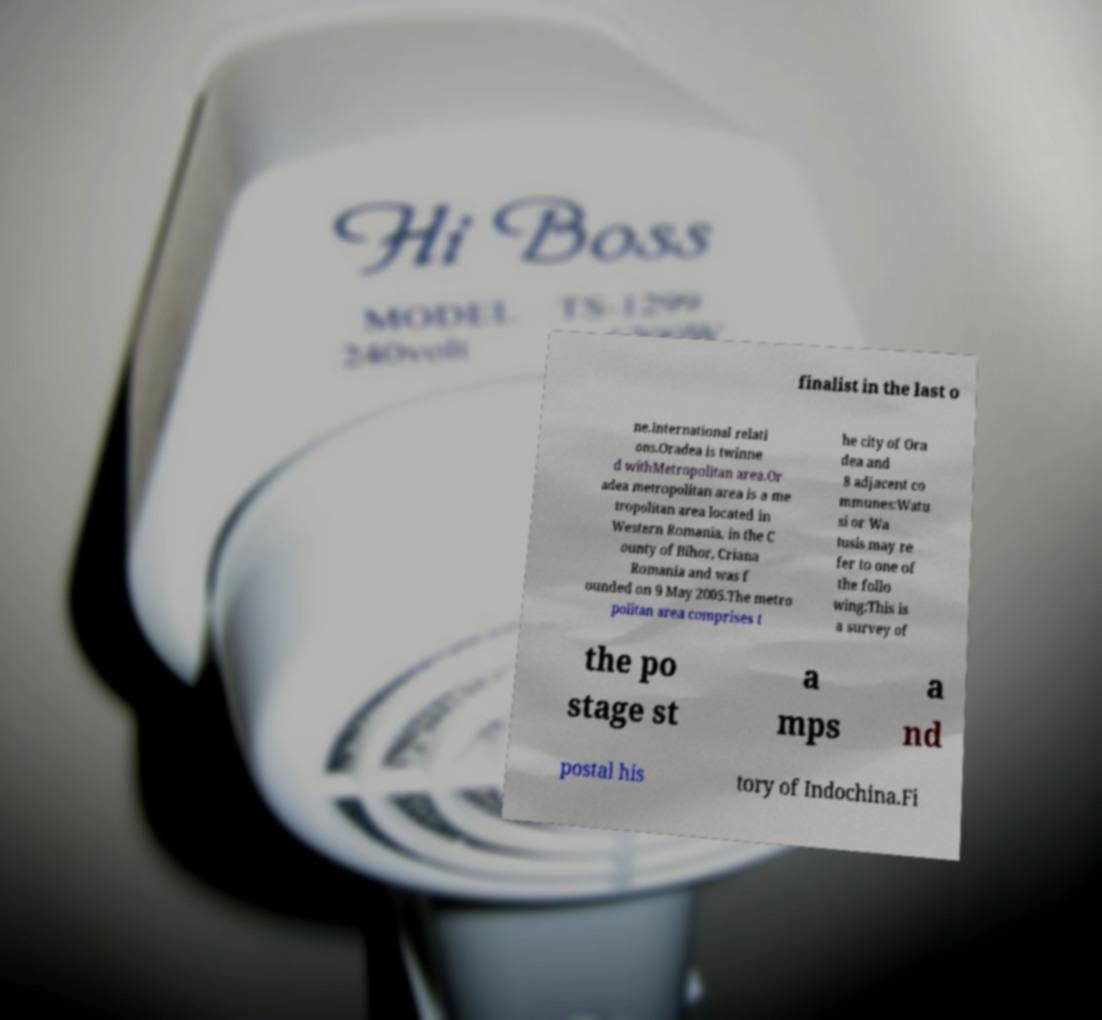Please identify and transcribe the text found in this image. finalist in the last o ne.International relati ons.Oradea is twinne d withMetropolitan area.Or adea metropolitan area is a me tropolitan area located in Western Romania, in the C ounty of Bihor, Criana Romania and was f ounded on 9 May 2005.The metro politan area comprises t he city of Ora dea and 8 adjacent co mmunes:Watu si or Wa tusis may re fer to one of the follo wing:This is a survey of the po stage st a mps a nd postal his tory of Indochina.Fi 